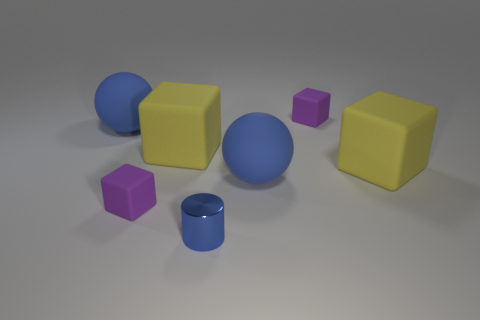Add 1 small cyan balls. How many objects exist? 8 Subtract all purple blocks. How many blocks are left? 2 Subtract 2 spheres. How many spheres are left? 0 Subtract all spheres. How many objects are left? 5 Subtract all cyan balls. How many red cylinders are left? 0 Subtract 0 gray blocks. How many objects are left? 7 Subtract all brown cylinders. Subtract all purple spheres. How many cylinders are left? 1 Subtract all purple rubber objects. Subtract all blue cylinders. How many objects are left? 4 Add 2 large blue rubber spheres. How many large blue rubber spheres are left? 4 Add 5 big gray metal things. How many big gray metal things exist? 5 